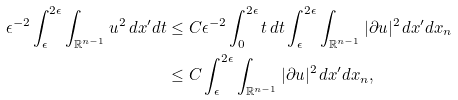<formula> <loc_0><loc_0><loc_500><loc_500>\epsilon ^ { - 2 } \int _ { \epsilon } ^ { 2 \epsilon } \int _ { \mathbb { R } ^ { n - 1 } } u ^ { 2 } \, d x ^ { \prime } d t & \leq C \epsilon ^ { - 2 } \int _ { 0 } ^ { 2 \epsilon } t \, d t \int _ { \epsilon } ^ { 2 \epsilon } \int _ { \mathbb { R } ^ { n - 1 } } | \partial u | ^ { 2 } \, d x ^ { \prime } d x _ { n } \\ & \leq C \int _ { \epsilon } ^ { 2 \epsilon } \int _ { \mathbb { R } ^ { n - 1 } } | \partial u | ^ { 2 } \, d x ^ { \prime } d x _ { n } ,</formula> 